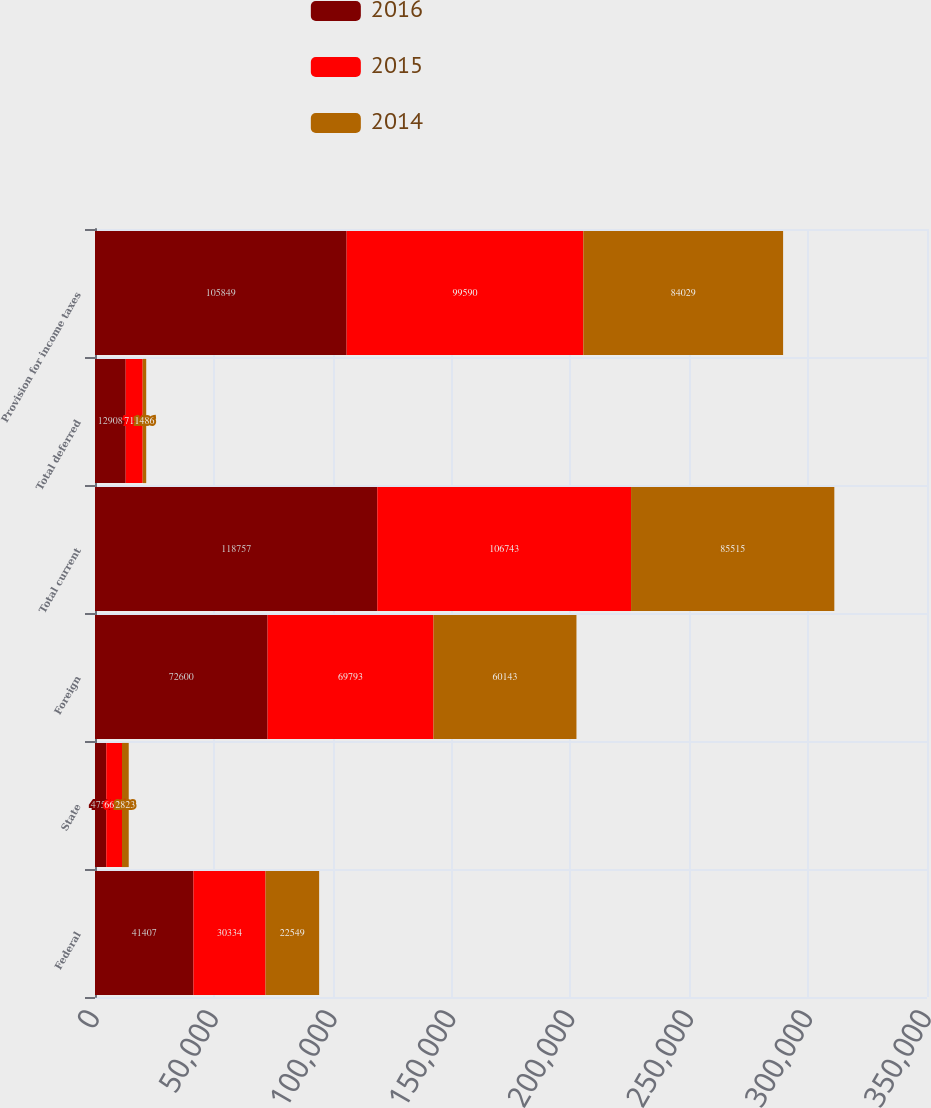Convert chart to OTSL. <chart><loc_0><loc_0><loc_500><loc_500><stacked_bar_chart><ecel><fcel>Federal<fcel>State<fcel>Foreign<fcel>Total current<fcel>Total deferred<fcel>Provision for income taxes<nl><fcel>2016<fcel>41407<fcel>4750<fcel>72600<fcel>118757<fcel>12908<fcel>105849<nl><fcel>2015<fcel>30334<fcel>6616<fcel>69793<fcel>106743<fcel>7153<fcel>99590<nl><fcel>2014<fcel>22549<fcel>2823<fcel>60143<fcel>85515<fcel>1486<fcel>84029<nl></chart> 